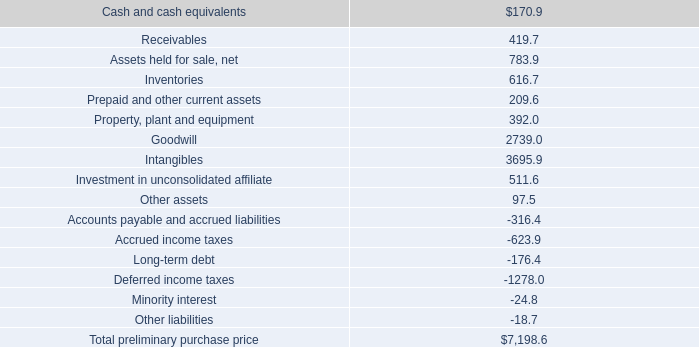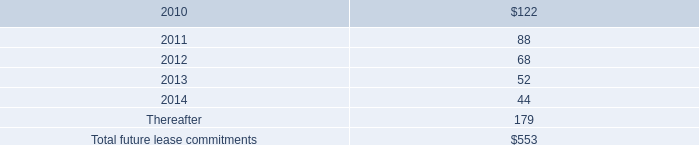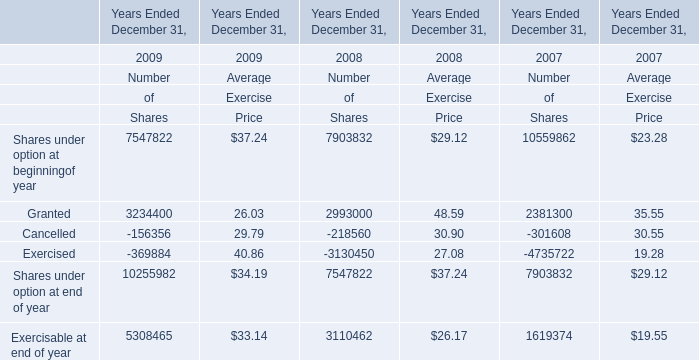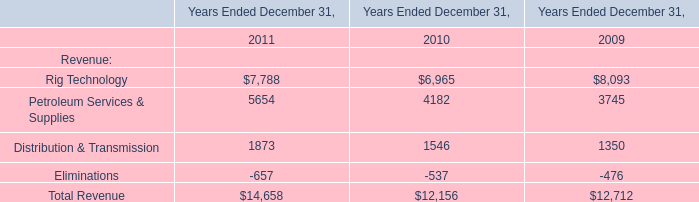What will Number of Shares for Shares under option at end of year Ended December 31 reach in 2010 if it continues to grow at its current rate? 
Computations: (10255982 * (1 + ((10255982 - 7547822) / 7547822)))
Answer: 13935830.33414. 